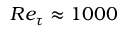<formula> <loc_0><loc_0><loc_500><loc_500>R e _ { \tau } \approx 1 0 0 0</formula> 